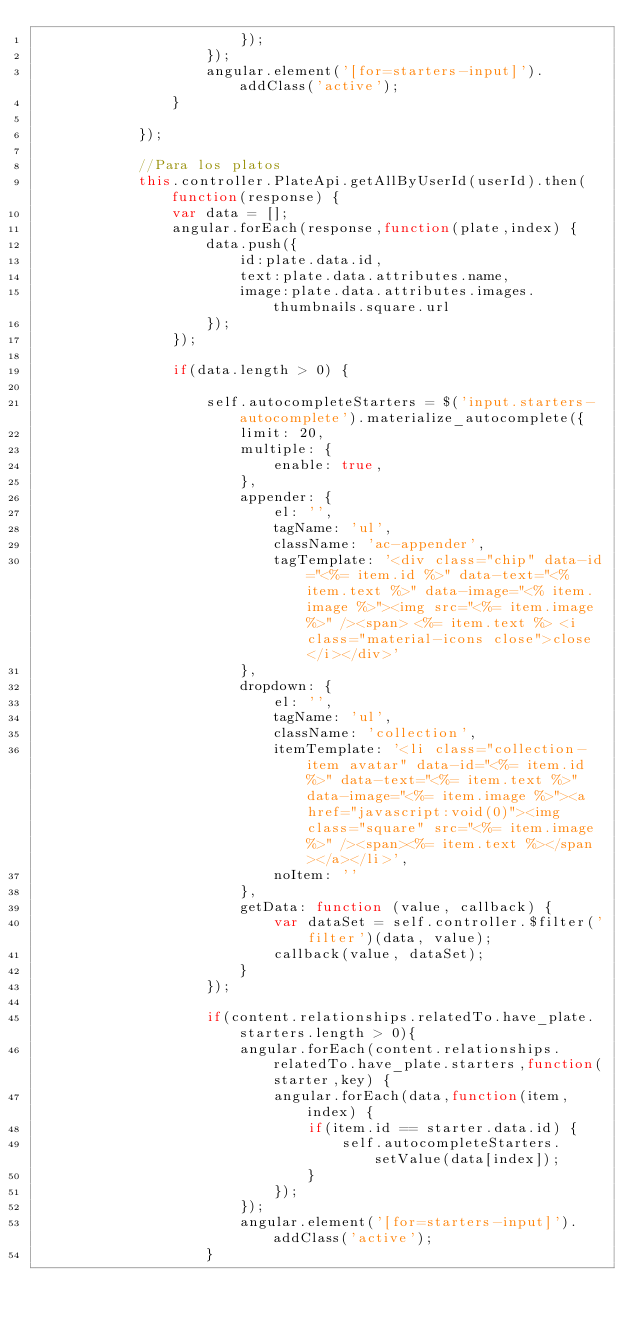<code> <loc_0><loc_0><loc_500><loc_500><_TypeScript_>                        });
                    });
                    angular.element('[for=starters-input]').addClass('active');
                }

            });

            //Para los platos
            this.controller.PlateApi.getAllByUserId(userId).then(function(response) {
                var data = [];
                angular.forEach(response,function(plate,index) {
                    data.push({
                        id:plate.data.id,
                        text:plate.data.attributes.name,
                        image:plate.data.attributes.images.thumbnails.square.url
                    });
                });

                if(data.length > 0) {

                    self.autocompleteStarters = $('input.starters-autocomplete').materialize_autocomplete({
                        limit: 20,
                        multiple: {
                            enable: true,
                        },
                        appender: {
                            el: '',
                            tagName: 'ul',
                            className: 'ac-appender',
                            tagTemplate: '<div class="chip" data-id="<%= item.id %>" data-text="<% item.text %>" data-image="<% item.image %>"><img src="<%= item.image %>" /><span> <%= item.text %> <i class="material-icons close">close</i></div>'
                        },
                        dropdown: {
                            el: '',
                            tagName: 'ul',
                            className: 'collection',
                            itemTemplate: '<li class="collection-item avatar" data-id="<%= item.id %>" data-text="<%= item.text %>" data-image="<%= item.image %>"><a href="javascript:void(0)"><img class="square" src="<%= item.image %>" /><span><%= item.text %></span></a></li>',
                            noItem: ''
                        },
                        getData: function (value, callback) {
                            var dataSet = self.controller.$filter('filter')(data, value);
                            callback(value, dataSet);
                        }
                    });

                    if(content.relationships.relatedTo.have_plate.starters.length > 0){
                        angular.forEach(content.relationships.relatedTo.have_plate.starters,function(starter,key) {
                            angular.forEach(data,function(item,index) {
                                if(item.id == starter.data.id) {
                                    self.autocompleteStarters.setValue(data[index]);
                                }
                            });
                        });
                        angular.element('[for=starters-input]').addClass('active');
                    }
</code> 